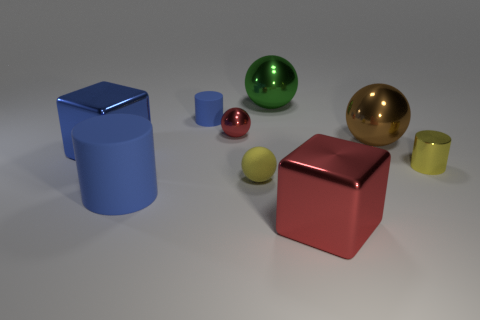Subtract all rubber cylinders. How many cylinders are left? 1 Subtract all red spheres. How many spheres are left? 3 Subtract 1 spheres. How many spheres are left? 3 Add 7 tiny yellow cylinders. How many tiny yellow cylinders are left? 8 Add 7 red blocks. How many red blocks exist? 8 Subtract 0 gray cylinders. How many objects are left? 9 Subtract all balls. How many objects are left? 5 Subtract all yellow cylinders. Subtract all cyan cubes. How many cylinders are left? 2 Subtract all red cubes. How many red cylinders are left? 0 Subtract all blue rubber cylinders. Subtract all tiny red metal cubes. How many objects are left? 7 